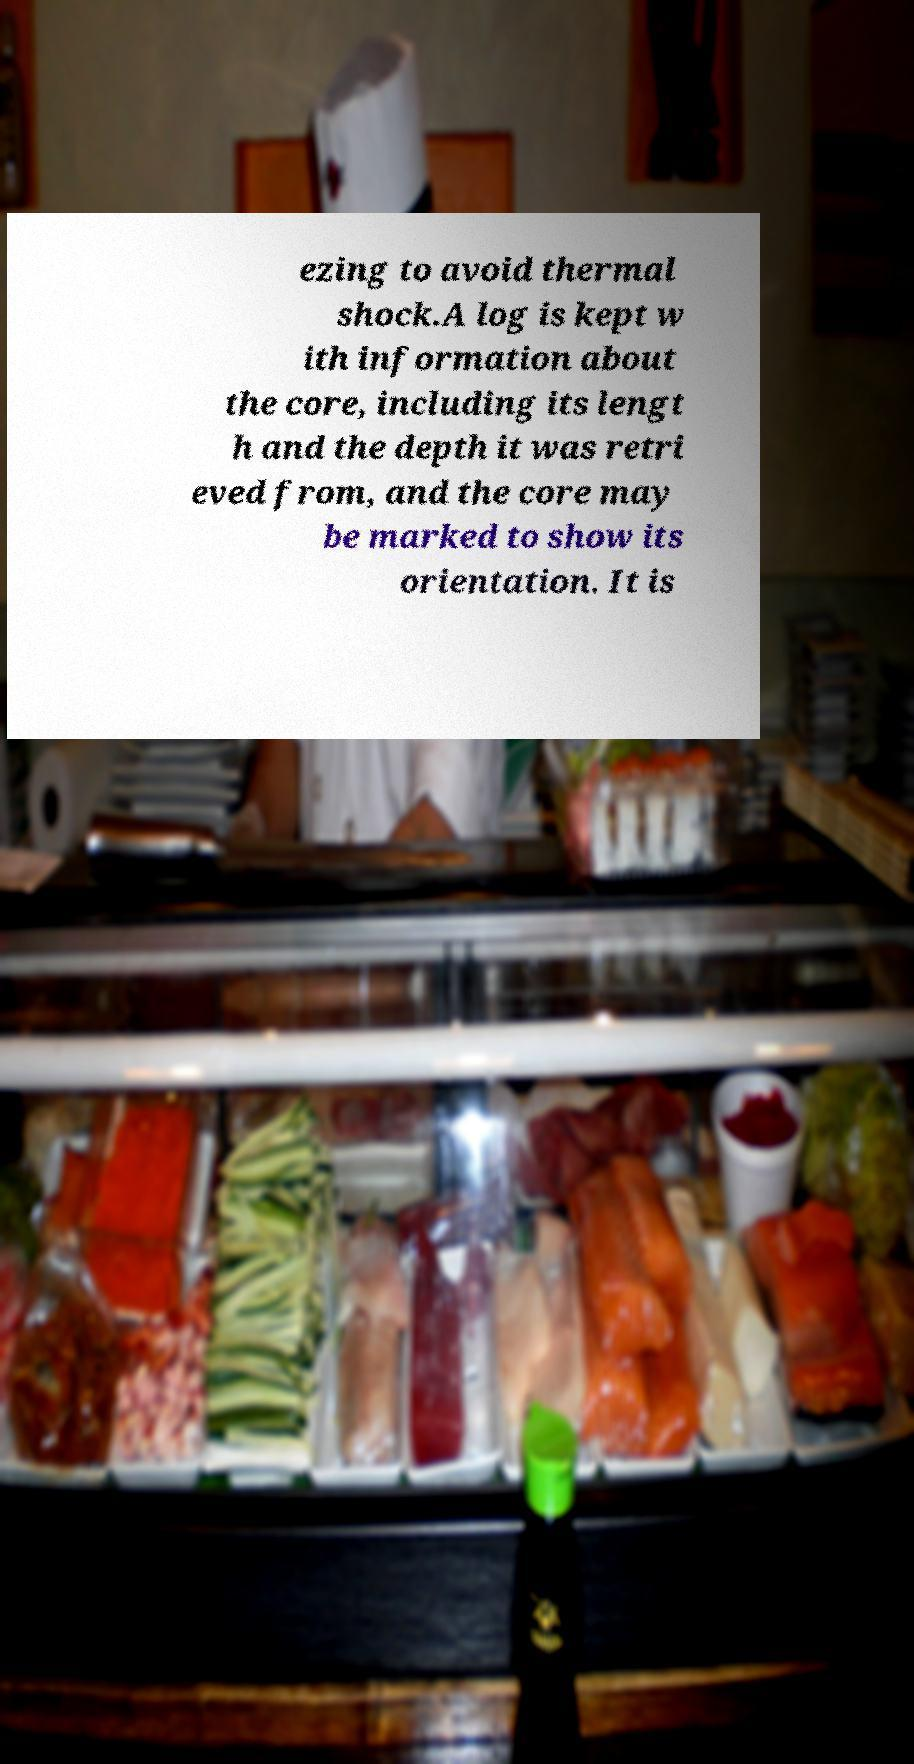Please read and relay the text visible in this image. What does it say? ezing to avoid thermal shock.A log is kept w ith information about the core, including its lengt h and the depth it was retri eved from, and the core may be marked to show its orientation. It is 